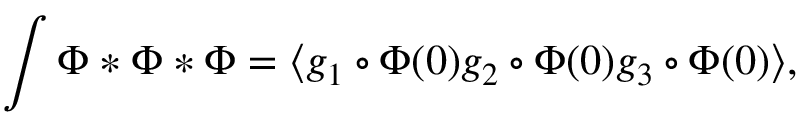<formula> <loc_0><loc_0><loc_500><loc_500>\int \Phi * \Phi * \Phi = \langle g _ { 1 } \circ \Phi ( 0 ) g _ { 2 } \circ \Phi ( 0 ) g _ { 3 } \circ \Phi ( 0 ) \rangle ,</formula> 